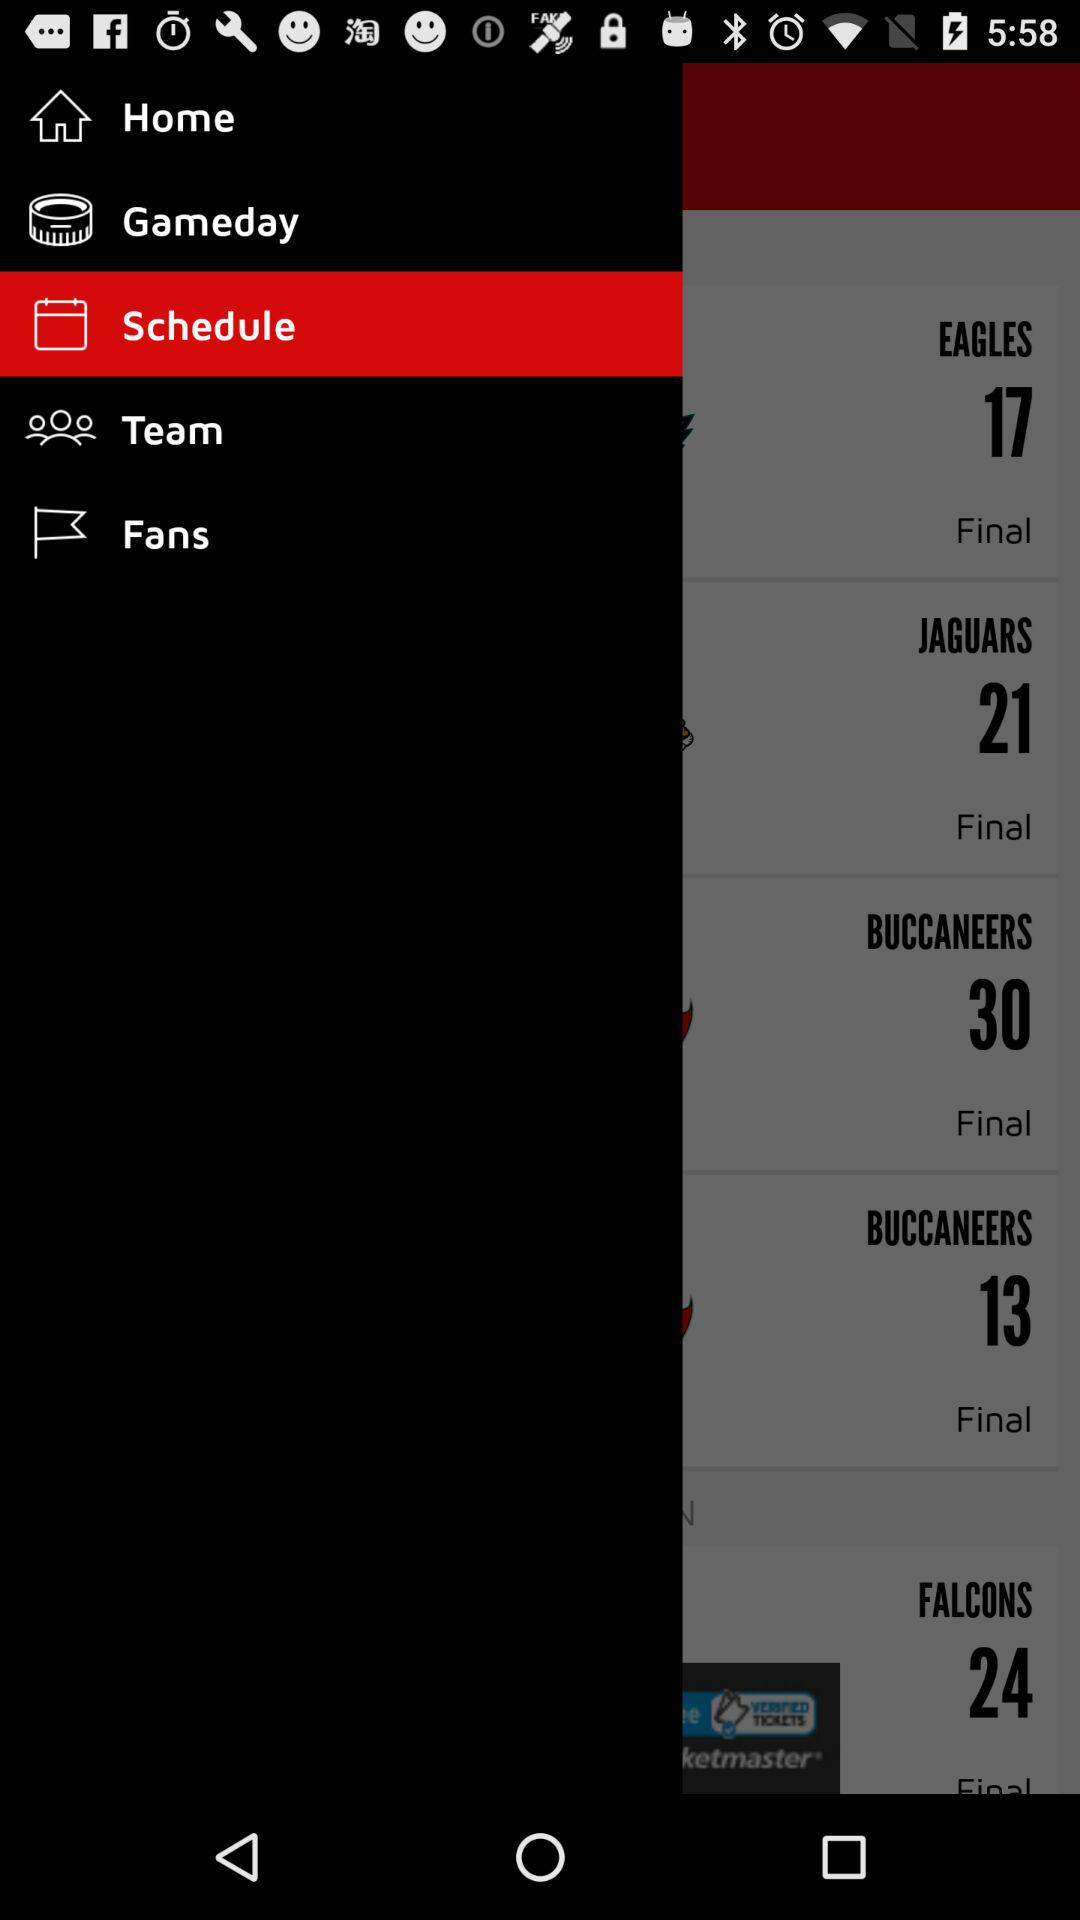How many more points did the Falcons score than the Buccaneers?
Answer the question using a single word or phrase. 11 